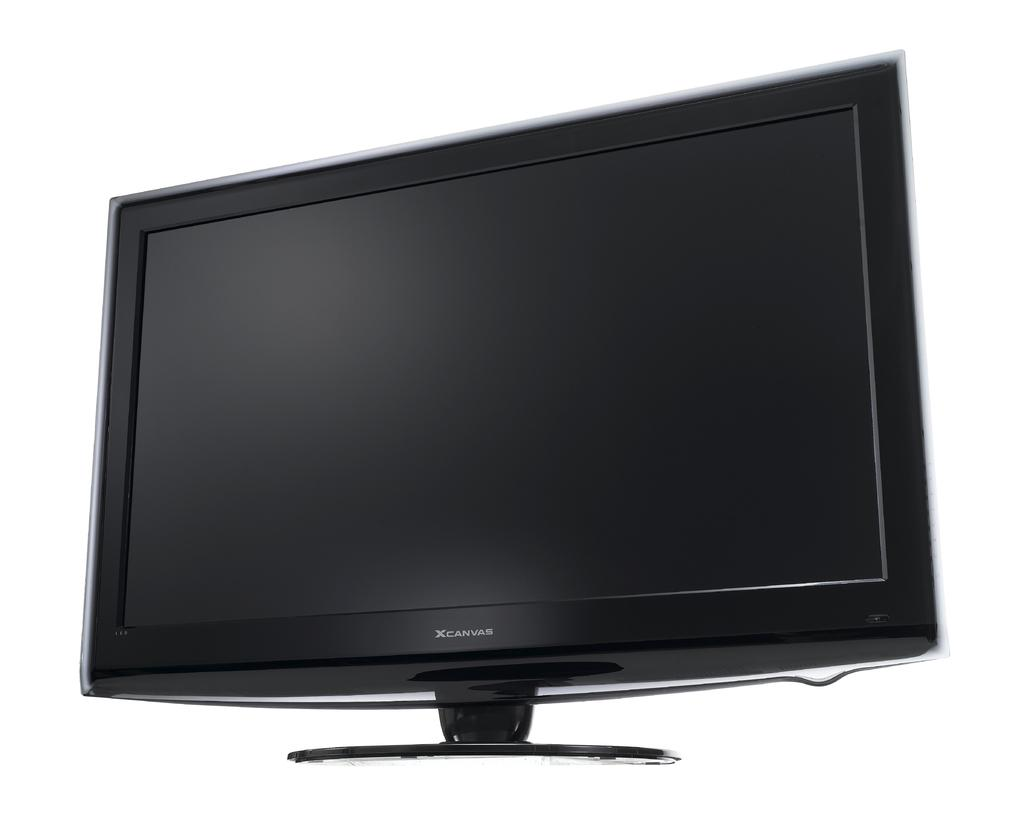<image>
Relay a brief, clear account of the picture shown. A television set standing on a black base with the name XCanvas. 